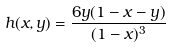Convert formula to latex. <formula><loc_0><loc_0><loc_500><loc_500>h ( x , y ) = \frac { 6 y ( 1 - x - y ) } { ( 1 - x ) ^ { 3 } }</formula> 